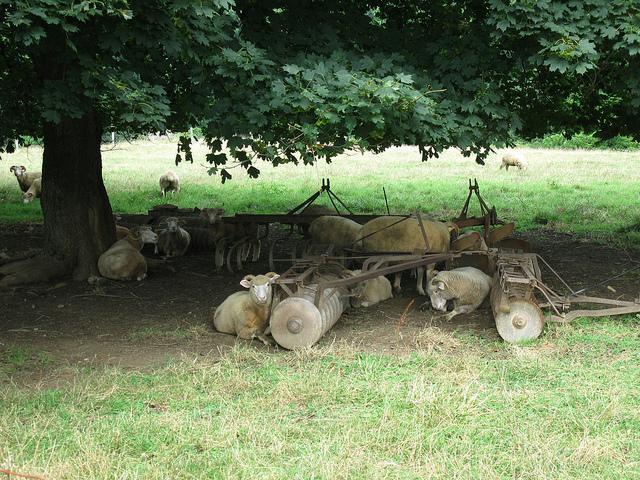How many sheep are in the photo?
Give a very brief answer. 4. How many zebra tails can be seen?
Give a very brief answer. 0. 